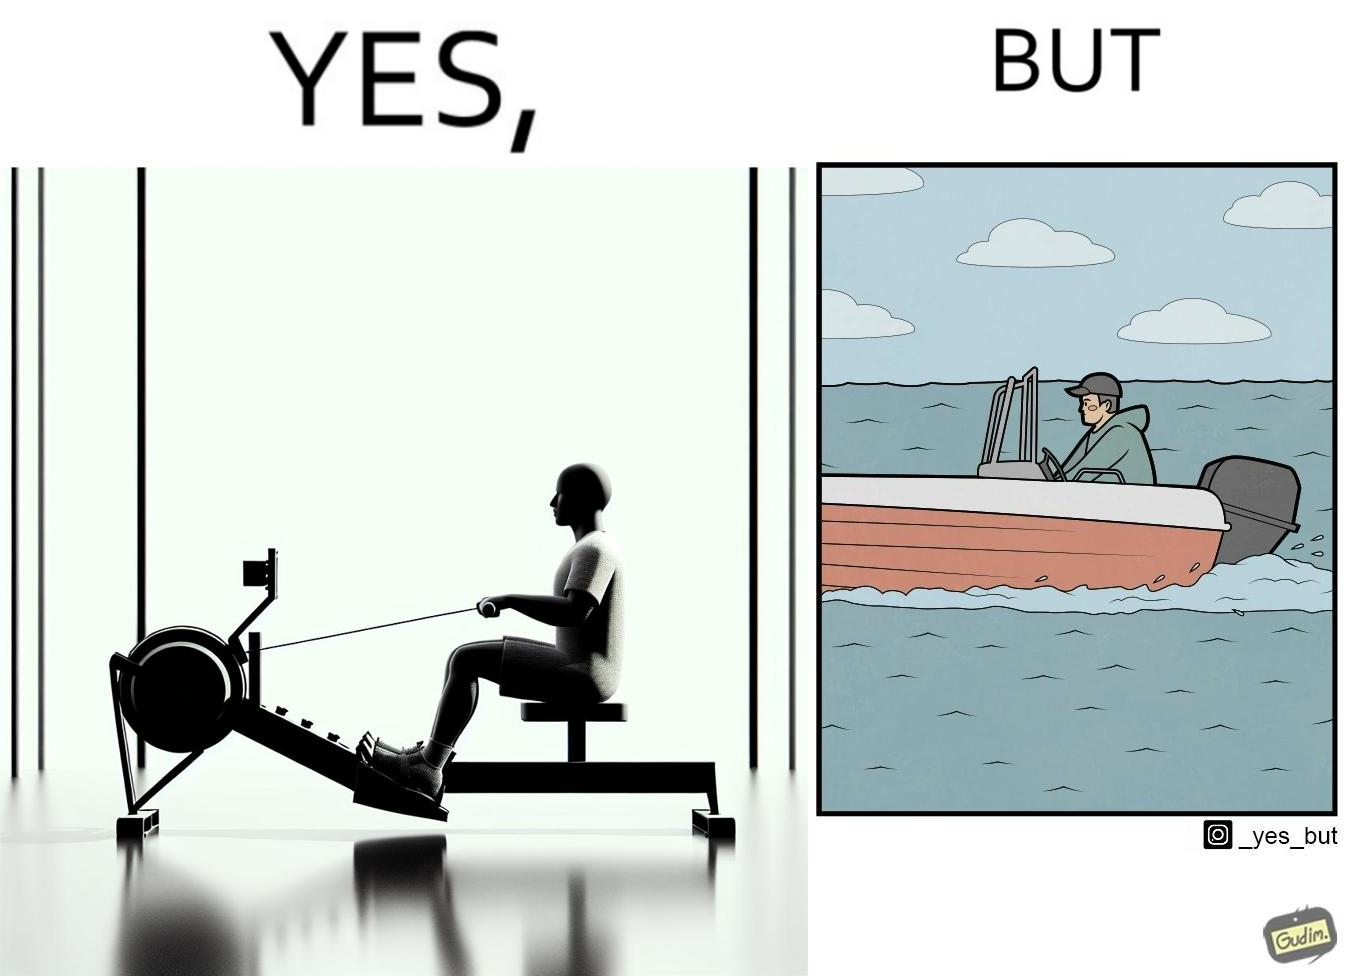Compare the left and right sides of this image. In the left part of the image: a person doing rowing exercise in gym In the right part of the image: a person riding a motorboat 